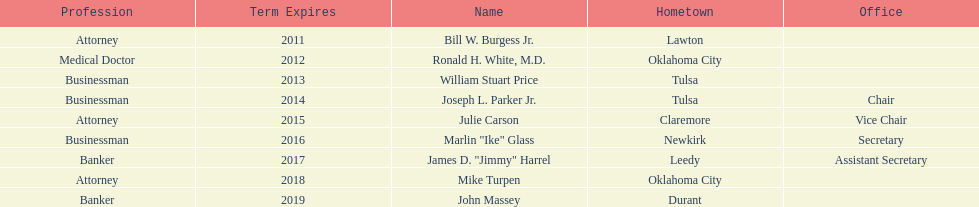What is the total amount of current state regents who are bankers? 2. 